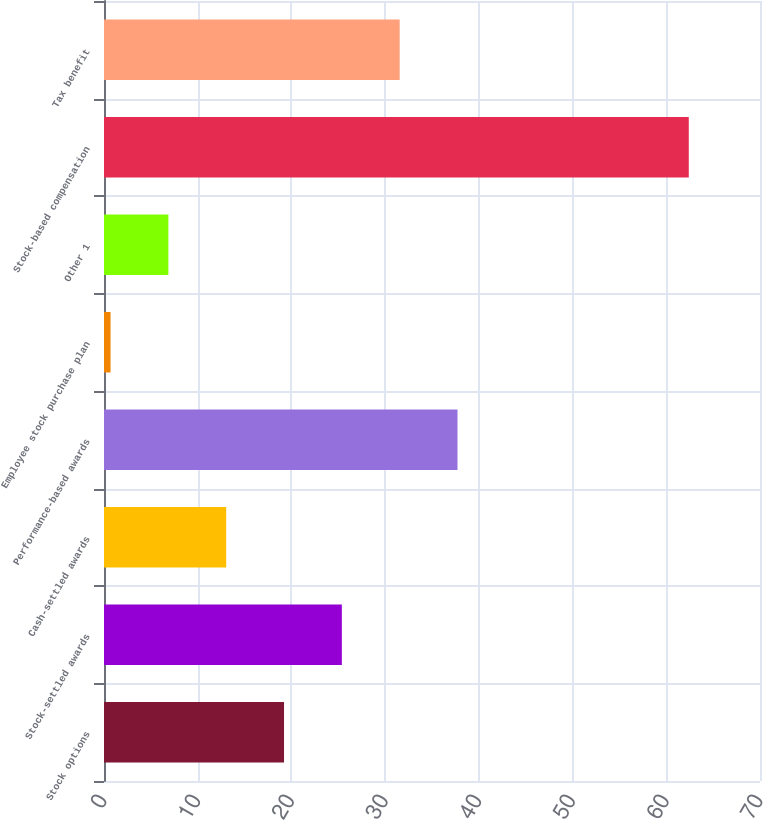Convert chart. <chart><loc_0><loc_0><loc_500><loc_500><bar_chart><fcel>Stock options<fcel>Stock-settled awards<fcel>Cash-settled awards<fcel>Performance-based awards<fcel>Employee stock purchase plan<fcel>Other 1<fcel>Stock-based compensation<fcel>Tax benefit<nl><fcel>19.21<fcel>25.38<fcel>13.04<fcel>37.72<fcel>0.7<fcel>6.87<fcel>62.4<fcel>31.55<nl></chart> 